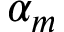Convert formula to latex. <formula><loc_0><loc_0><loc_500><loc_500>\alpha _ { m }</formula> 